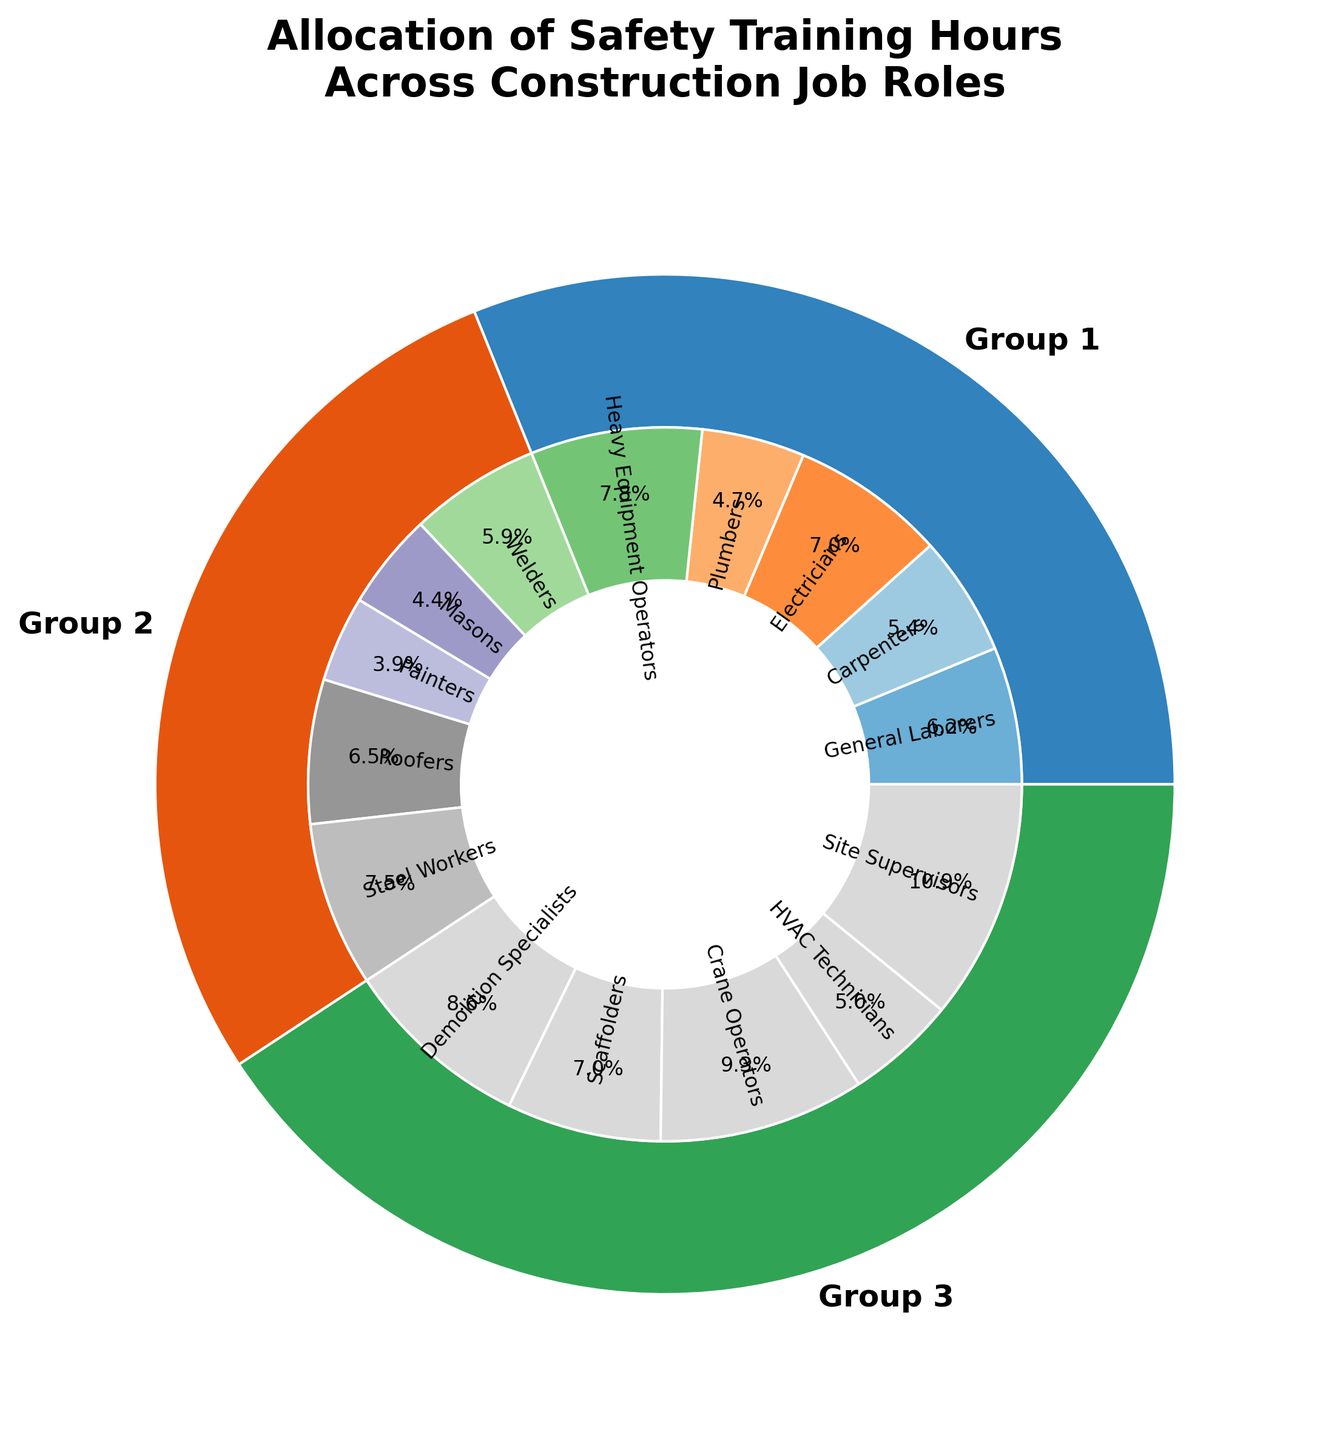What percentage of the total safety training hours is allocated to Site Supervisors? Site Supervisors account for one wedge in the inner pie chart. Identify the corresponding percentage label inside that wedge, which can be read directly from the figure.
Answer: 12.1% Compare the total safety training hours for Site Supervisors and General Laborers. Which one is higher and by how much? From the figure, Site Supervisors are allocated 70 training hours while General Laborers have 40 training hours. Subtract the hours for General Laborers from those for Site Supervisors, i.e., 70 - 40.
Answer: Site Supervisors by 30 hours Are the safety training hours for Crane Operators more than those for Steel Workers? Locate the wedges for Crane Operators and Steel Workers in the inner pie chart and compare the percentages or training hours directly.
Answer: Yes Which job role has the smallest portion of allocated safety training hours? Examine the inner pie chart to identify the smallest wedge by comparing their sizes or looking at their percentage labels.
Answer: Painters Which group (Group 1, Group 2, or Group 3) has the highest total training hours? Sum up the values indicated for Groups 1, 2, and 3 in the outer pie chart. Compare these summed values to determine which group is the largest. Group 1 has a total of 200 hours, Group 2 has a total of 181 hours, and Group 3 has a total of 262 hours.
Answer: Group 3 What is the total number of safety training hours allocated to Heavy Equipment Operators, Roofers, and Scaffolders combined? Locate the wedges for Heavy Equipment Operators, Roofers, and Scaffolders, and sum their corresponding training hours (50 + 42 + 45).
Answer: 137 hours Are the training hours for Electricians and Scaffolders equal? Identify the wedges for Electricians and Scaffolders in the inner pie chart and check if their percentage labels or training hours are the same. Both Electricians and Scaffolders have 45 hours each.
Answer: Yes What are the total safety training hours allocated in Group 2? Sum up the training hours mentioned for Group 2 which include Welders (38), Masons (28), Painters (25), Roofers (42), and Steel Workers (48).
Answer: 181 hours 